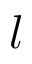<formula> <loc_0><loc_0><loc_500><loc_500>l</formula> 